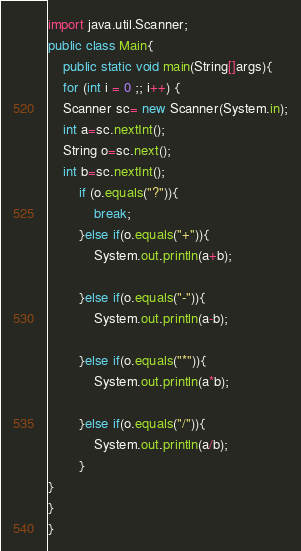<code> <loc_0><loc_0><loc_500><loc_500><_Java_>import java.util.Scanner;
public class Main{
	public static void main(String[]args){
	for (int i = 0 ;; i++) {
	Scanner sc= new Scanner(System.in);
	int a=sc.nextInt();
	String o=sc.next();
	int b=sc.nextInt();
		if (o.equals("?")){
			break;
		}else if(o.equals("+")){
			System.out.println(a+b);

		}else if(o.equals("-")){
			System.out.println(a-b);

		}else if(o.equals("*")){
			System.out.println(a*b);

		}else if(o.equals("/")){
			System.out.println(a/b);
		}
}
}
}</code> 